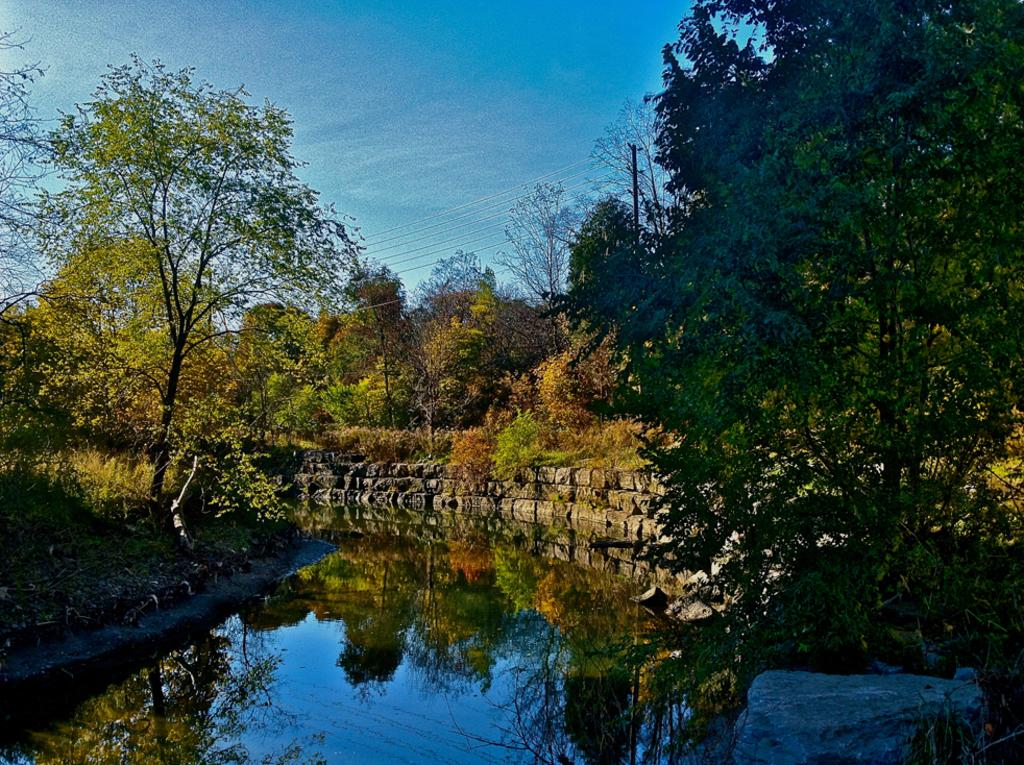What is the primary element visible in the image? There is water in the image. What type of vegetation can be seen in the image? There are trees in the image. What is the ground made of on either side of the water? There is greenery ground on either side of the water. How many stems can be seen on the cattle in the image? There are no cattle present in the image, and therefore no stems can be observed. 